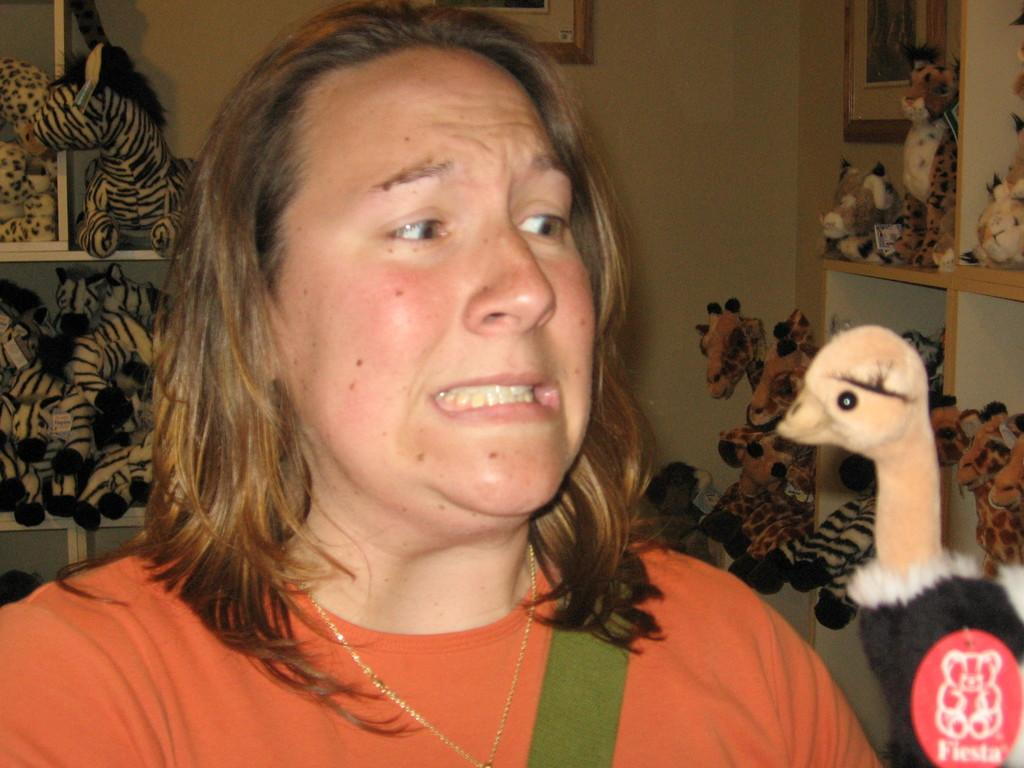What is the woman in the image doing? There is no woman present in the image; it features a man holding a guitar and standing in front of a microphone. What type of honey can be seen dripping from the microphone in the image? There is no honey present in the image, and the microphone is not depicted as dripping anything. Can you describe the person's toothbrush in the image? There is no toothbrush present in the image; it features a man holding a guitar and standing in front of a microphone. What type of crime is being committed in the image? There is no crime being committed in the image; it features a man holding a guitar and standing in front of a microphone. 